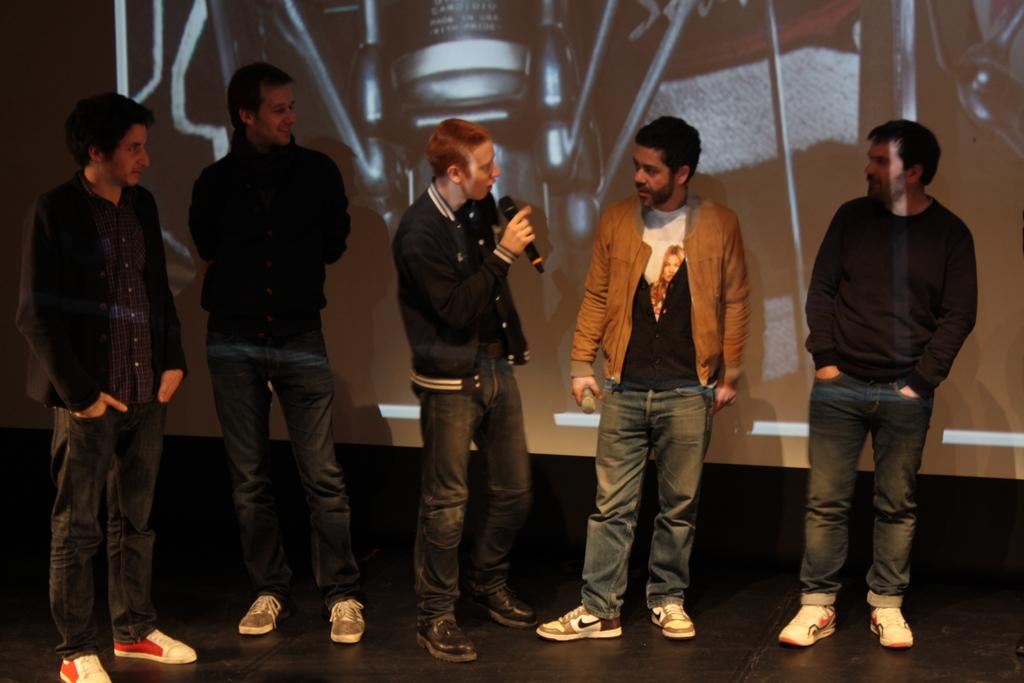How many people are present in the image? There are five people in the image. Where are the people located? The people are standing on a stage. What is one person doing in the image? One person is speaking into a microphone. What are the other people doing in the image? The other people are looking at the person speaking. What type of yarn is being used to create the microphone in the image? There is no yarn present in the image, and the microphone is not made of yarn. 